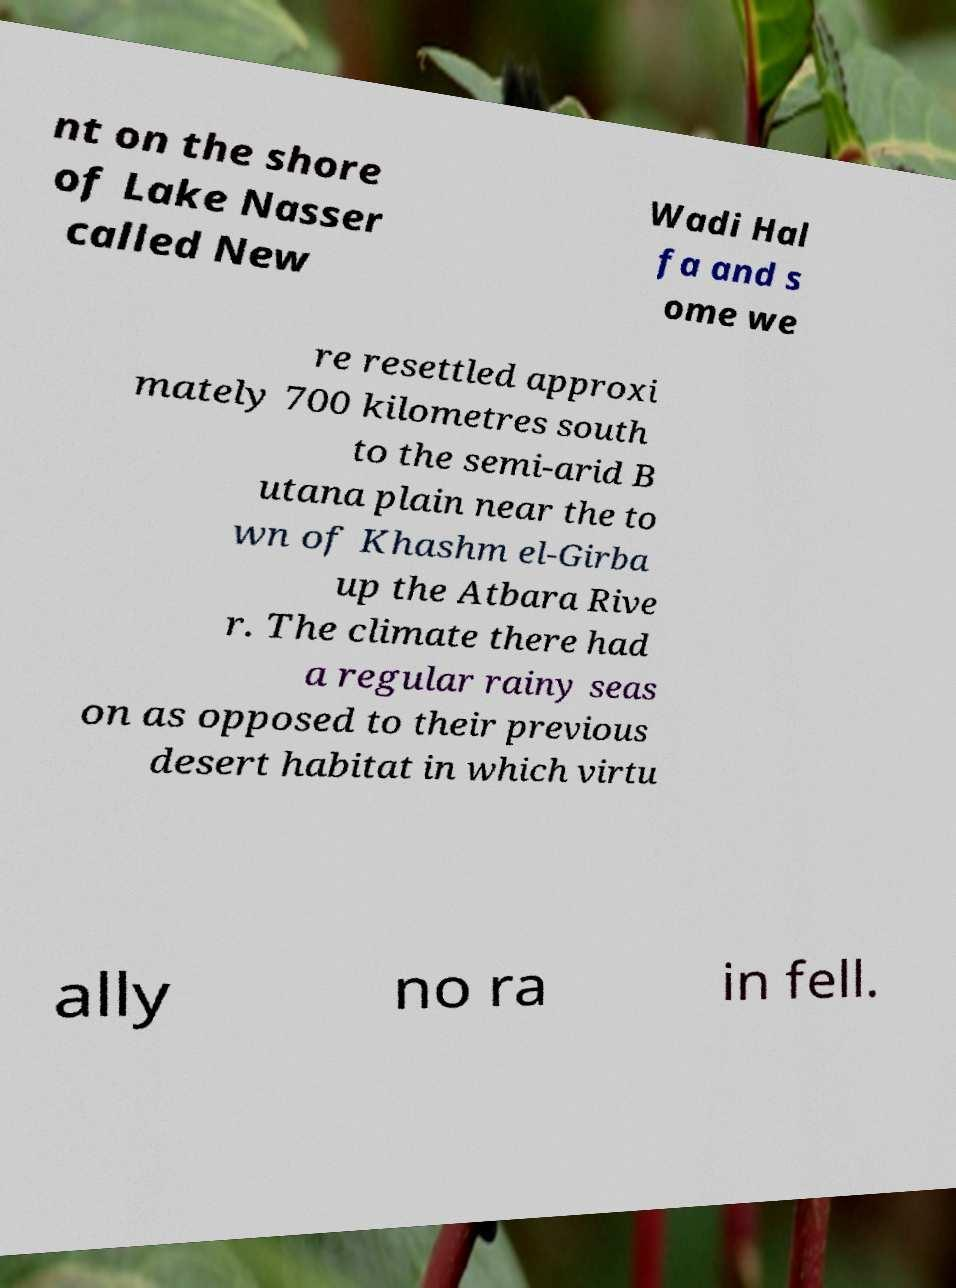Can you read and provide the text displayed in the image?This photo seems to have some interesting text. Can you extract and type it out for me? nt on the shore of Lake Nasser called New Wadi Hal fa and s ome we re resettled approxi mately 700 kilometres south to the semi-arid B utana plain near the to wn of Khashm el-Girba up the Atbara Rive r. The climate there had a regular rainy seas on as opposed to their previous desert habitat in which virtu ally no ra in fell. 